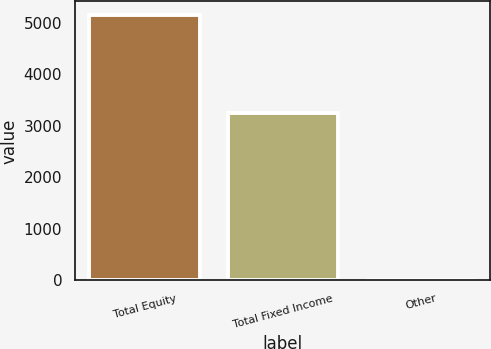Convert chart. <chart><loc_0><loc_0><loc_500><loc_500><bar_chart><fcel>Total Equity<fcel>Total Fixed Income<fcel>Other<nl><fcel>5161<fcel>3242<fcel>10<nl></chart> 